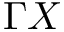Convert formula to latex. <formula><loc_0><loc_0><loc_500><loc_500>\Gamma X</formula> 